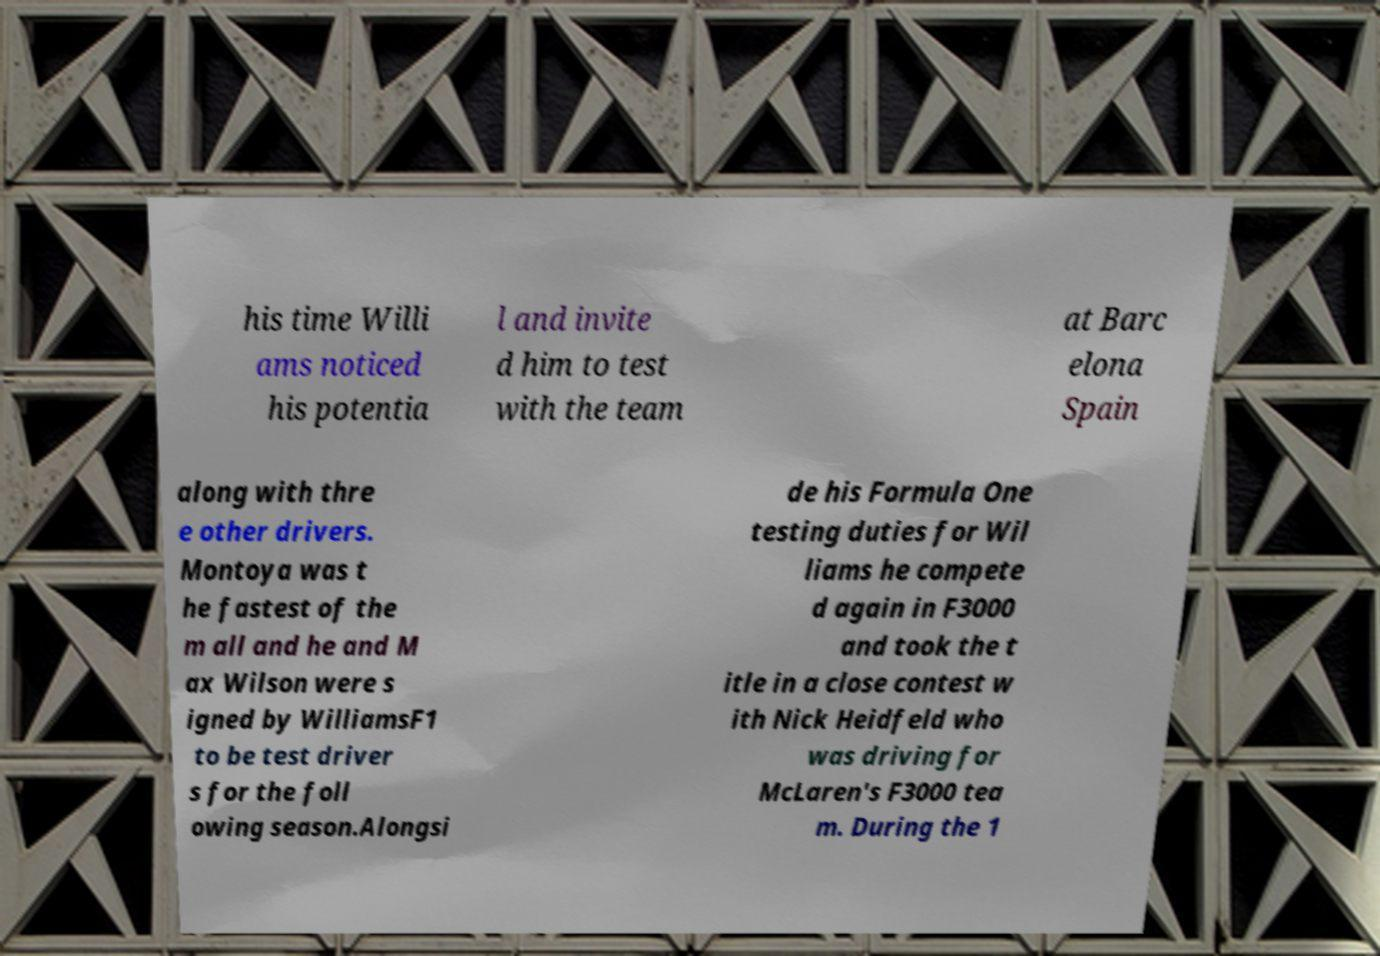Can you read and provide the text displayed in the image?This photo seems to have some interesting text. Can you extract and type it out for me? his time Willi ams noticed his potentia l and invite d him to test with the team at Barc elona Spain along with thre e other drivers. Montoya was t he fastest of the m all and he and M ax Wilson were s igned by WilliamsF1 to be test driver s for the foll owing season.Alongsi de his Formula One testing duties for Wil liams he compete d again in F3000 and took the t itle in a close contest w ith Nick Heidfeld who was driving for McLaren's F3000 tea m. During the 1 